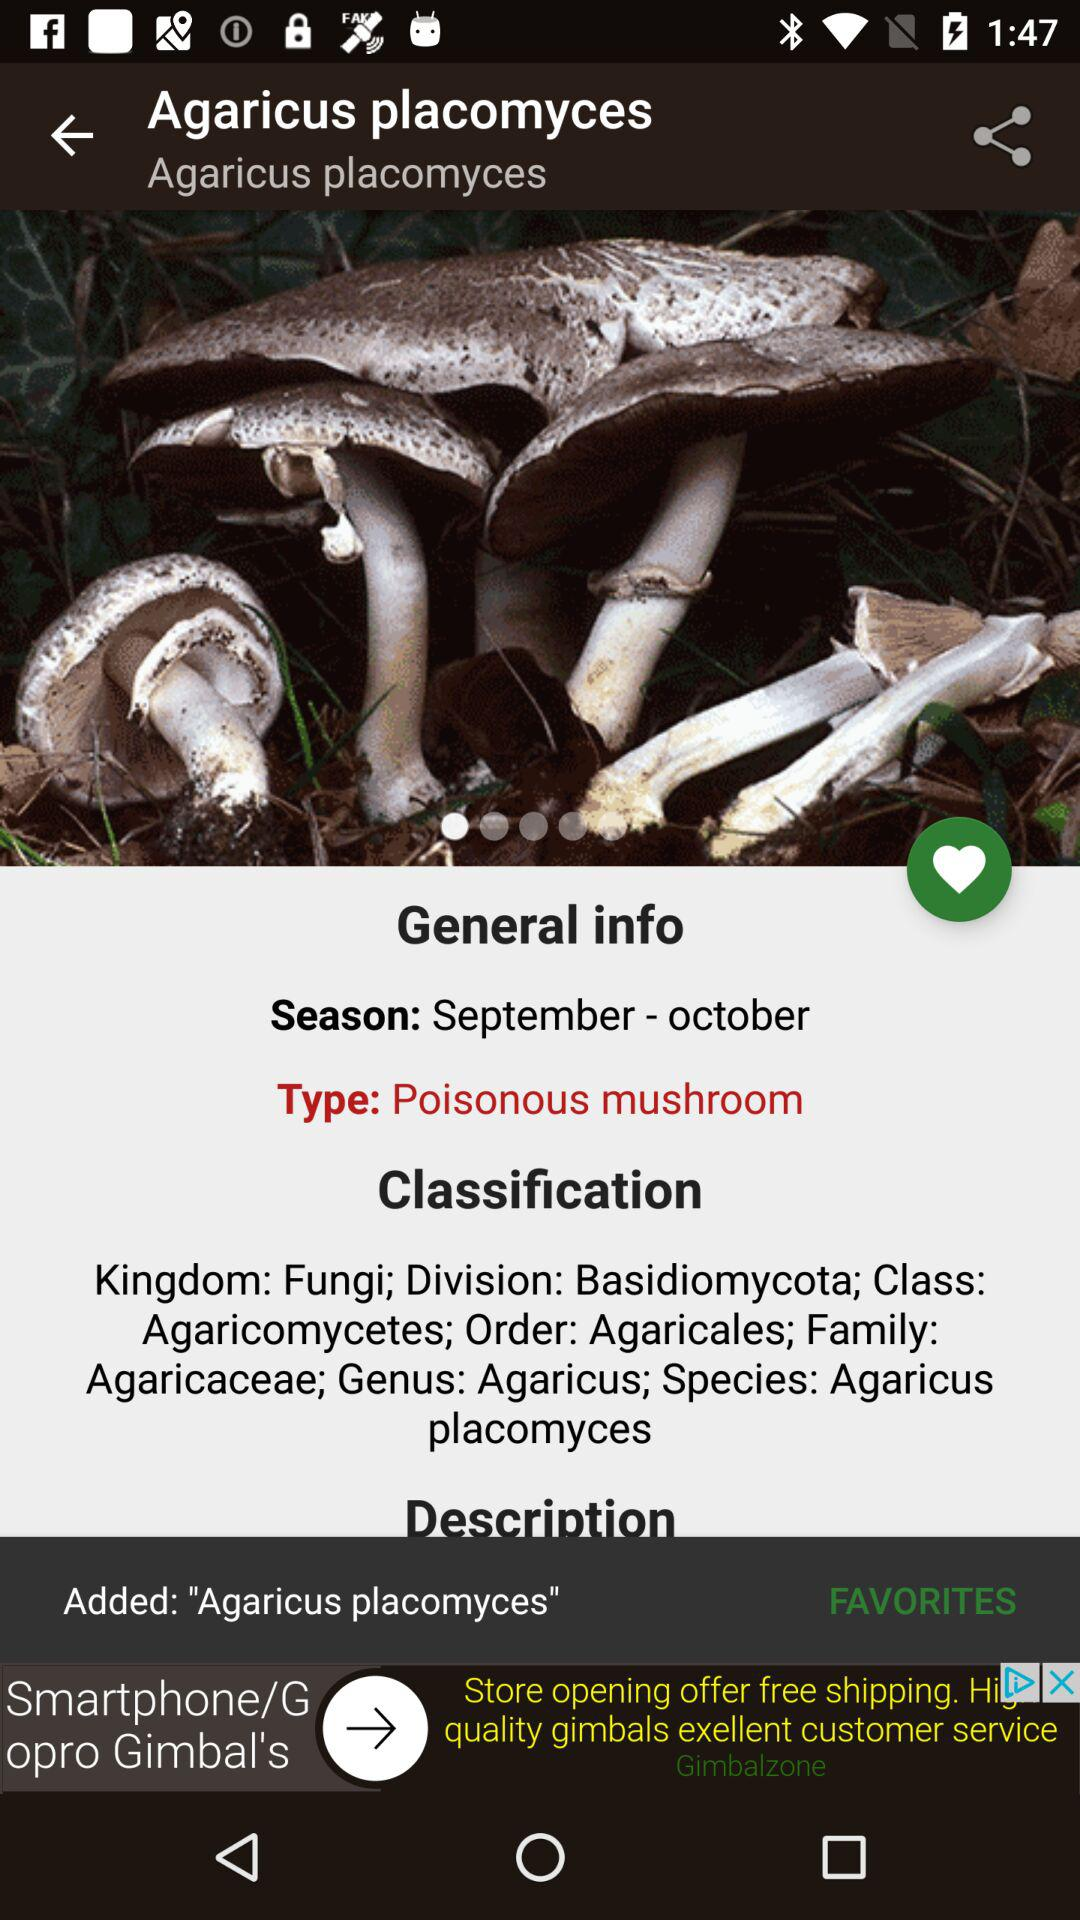Which is the suitable season? The suitable season is from September to October. 